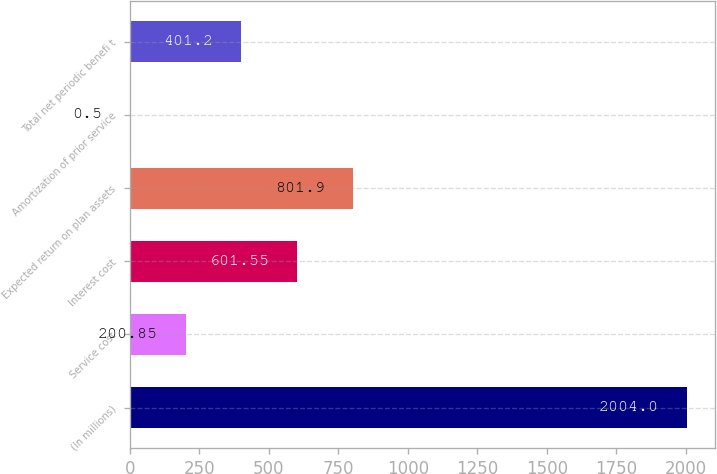<chart> <loc_0><loc_0><loc_500><loc_500><bar_chart><fcel>(In millions)<fcel>Service cost<fcel>Interest cost<fcel>Expected return on plan assets<fcel>Amortization of prior service<fcel>Total net periodic benefi t<nl><fcel>2004<fcel>200.85<fcel>601.55<fcel>801.9<fcel>0.5<fcel>401.2<nl></chart> 